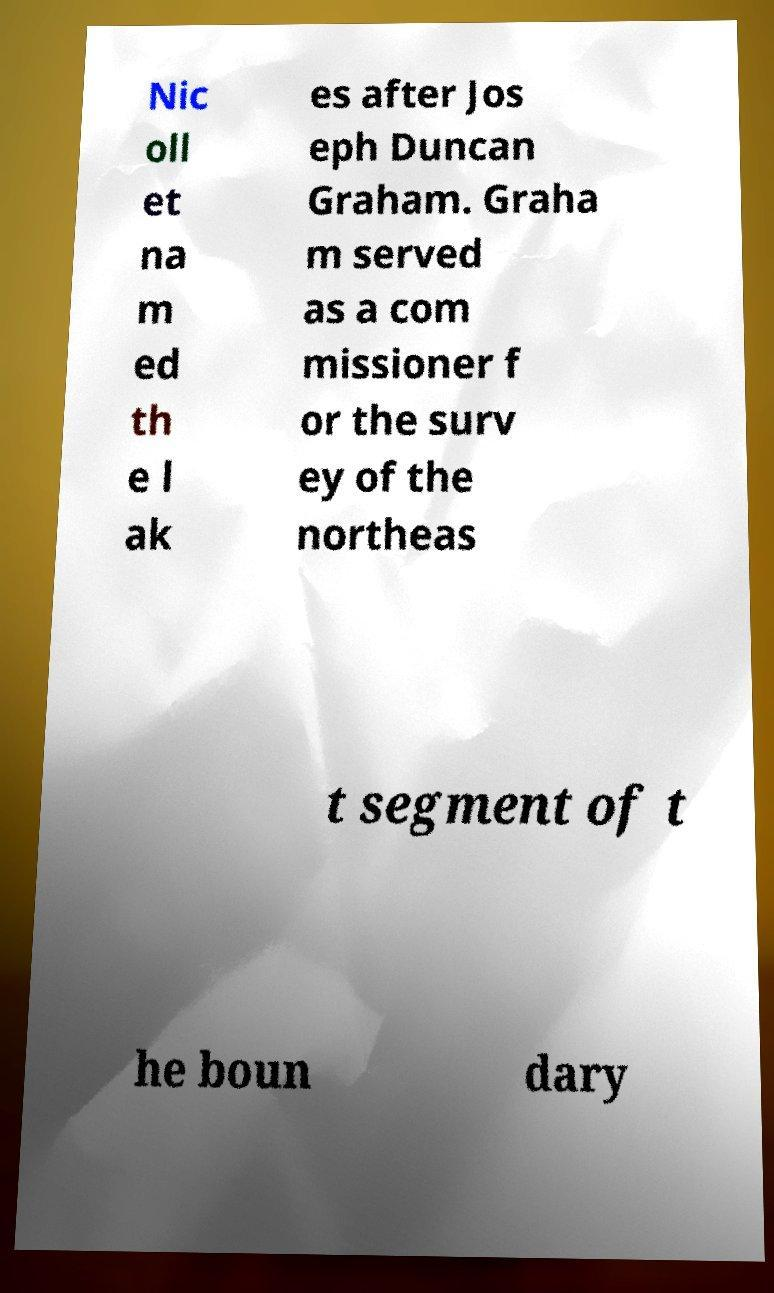Can you read and provide the text displayed in the image?This photo seems to have some interesting text. Can you extract and type it out for me? Nic oll et na m ed th e l ak es after Jos eph Duncan Graham. Graha m served as a com missioner f or the surv ey of the northeas t segment of t he boun dary 